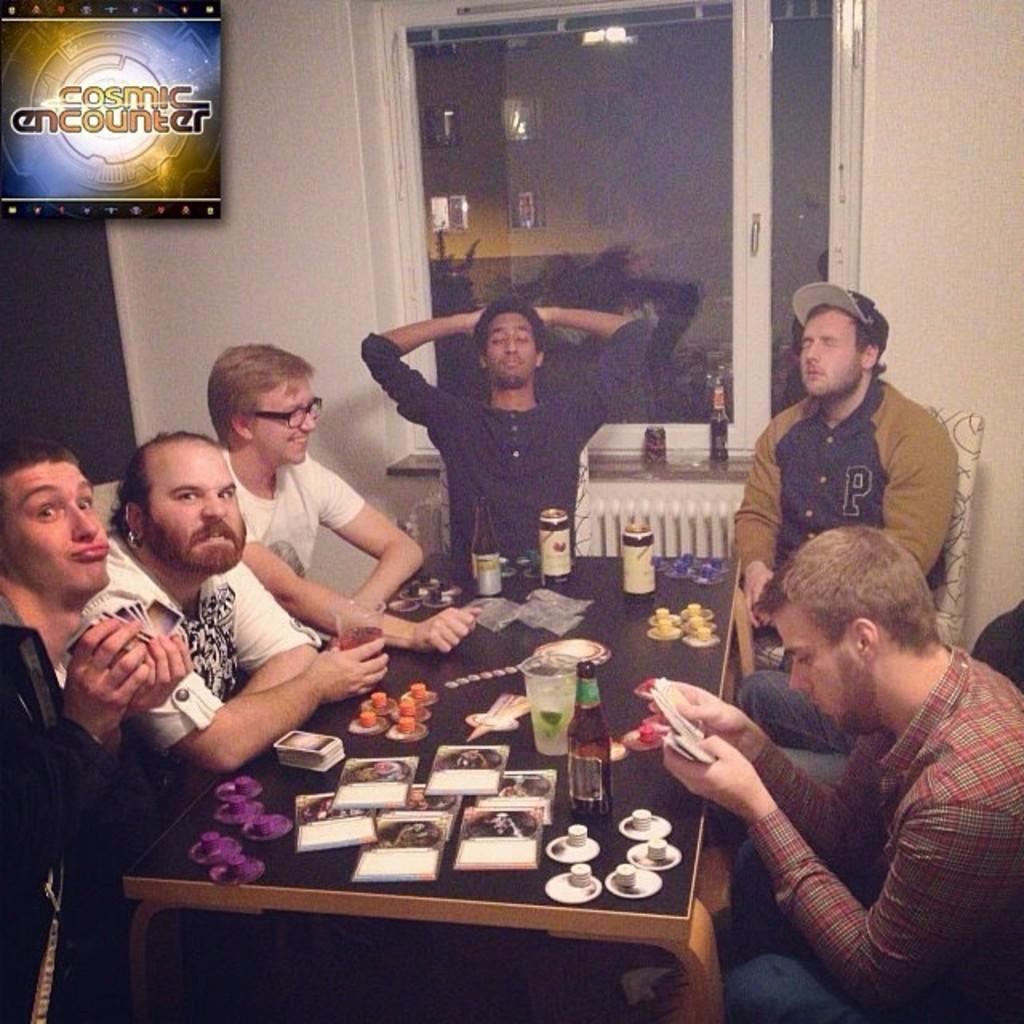Describe this image in one or two sentences. In the middle there is a table on that table there is a glass,bottle ,tin and some other items. On the right there is a man he is playing with cards he wear a checked shirt and trouser. On the left there are three men staring at something. In the background there is a window, glass ,poster, text. In the middle there is a man he wear a blue shirt. I think they all are playing cards. 